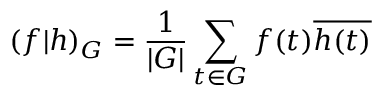Convert formula to latex. <formula><loc_0><loc_0><loc_500><loc_500>( f | h ) _ { G } = { \frac { 1 } { | G | } } \sum _ { t \in G } f ( t ) { \overline { h ( t ) } }</formula> 